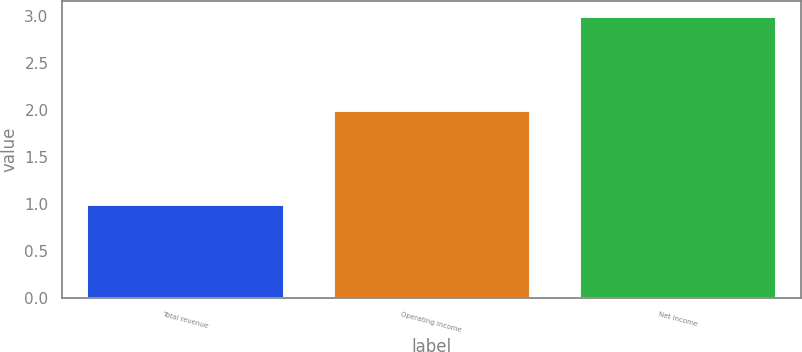Convert chart to OTSL. <chart><loc_0><loc_0><loc_500><loc_500><bar_chart><fcel>Total revenue<fcel>Operating income<fcel>Net income<nl><fcel>1<fcel>2<fcel>3<nl></chart> 